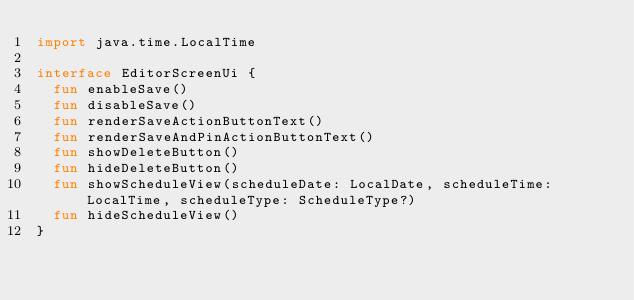<code> <loc_0><loc_0><loc_500><loc_500><_Kotlin_>import java.time.LocalTime

interface EditorScreenUi {
  fun enableSave()
  fun disableSave()
  fun renderSaveActionButtonText()
  fun renderSaveAndPinActionButtonText()
  fun showDeleteButton()
  fun hideDeleteButton()
  fun showScheduleView(scheduleDate: LocalDate, scheduleTime: LocalTime, scheduleType: ScheduleType?)
  fun hideScheduleView()
}
</code> 